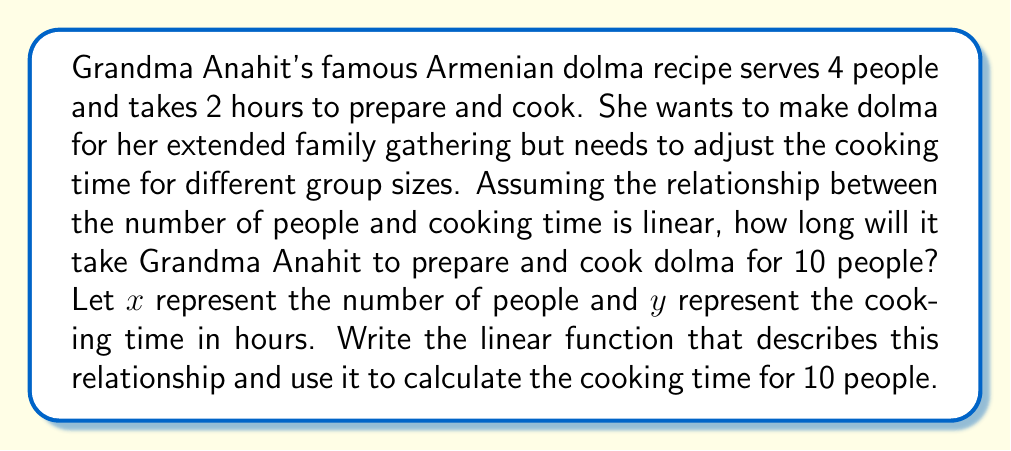Provide a solution to this math problem. To solve this problem, we'll follow these steps:

1. Identify the given information:
   - 4 people: 2 hours
   - The relationship is linear

2. Find the slope (rate of change) of the linear function:
   Let's use the point-slope form of a linear equation: $y - y_1 = m(x - x_1)$
   We know one point (4, 2), but we need to find the slope $m$.

   The slope represents the change in cooking time for each additional person.
   $m = \frac{\text{change in y}}{\text{change in x}} = \frac{2 \text{ hours}}{4 \text{ people}} = 0.5 \text{ hours/person}$

3. Write the linear function:
   Using the point-slope form: $y - 2 = 0.5(x - 4)$
   Simplify: $y = 0.5x - 2 + 2 = 0.5x$

   So, the linear function is: $y = 0.5x$

4. Calculate the cooking time for 10 people:
   Substitute $x = 10$ into the equation:
   $y = 0.5(10) = 5$

Therefore, it will take Grandma Anahit 5 hours to prepare and cook dolma for 10 people.
Answer: The linear function is $y = 0.5x$, where $x$ is the number of people and $y$ is the cooking time in hours. For 10 people, the cooking time will be 5 hours. 